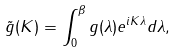<formula> <loc_0><loc_0><loc_500><loc_500>\tilde { g } ( K ) = \int _ { 0 } ^ { \beta } g ( \lambda ) e ^ { i K \lambda } d \lambda ,</formula> 